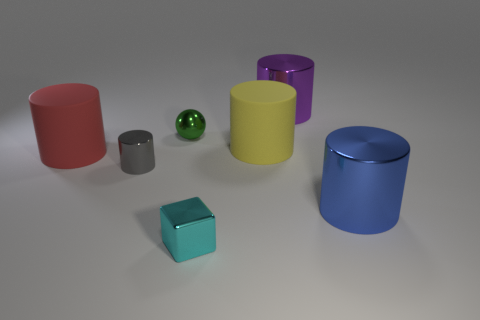Are there any other things that have the same color as the tiny shiny ball?
Your answer should be compact. No. What number of other objects are there of the same material as the big red object?
Provide a short and direct response. 1. What is the size of the red cylinder?
Your answer should be compact. Large. Are there any cyan things of the same shape as the big purple metal object?
Provide a succinct answer. No. How many objects are either tiny metallic spheres or large things right of the block?
Provide a succinct answer. 4. There is a large cylinder to the left of the cyan thing; what color is it?
Keep it short and to the point. Red. Does the thing that is in front of the blue cylinder have the same size as the matte thing that is in front of the big yellow cylinder?
Your response must be concise. No. Are there any yellow matte things of the same size as the blue cylinder?
Your answer should be very brief. Yes. How many purple things are on the left side of the large matte thing that is to the left of the cyan cube?
Ensure brevity in your answer.  0. What is the material of the big yellow cylinder?
Provide a short and direct response. Rubber. 